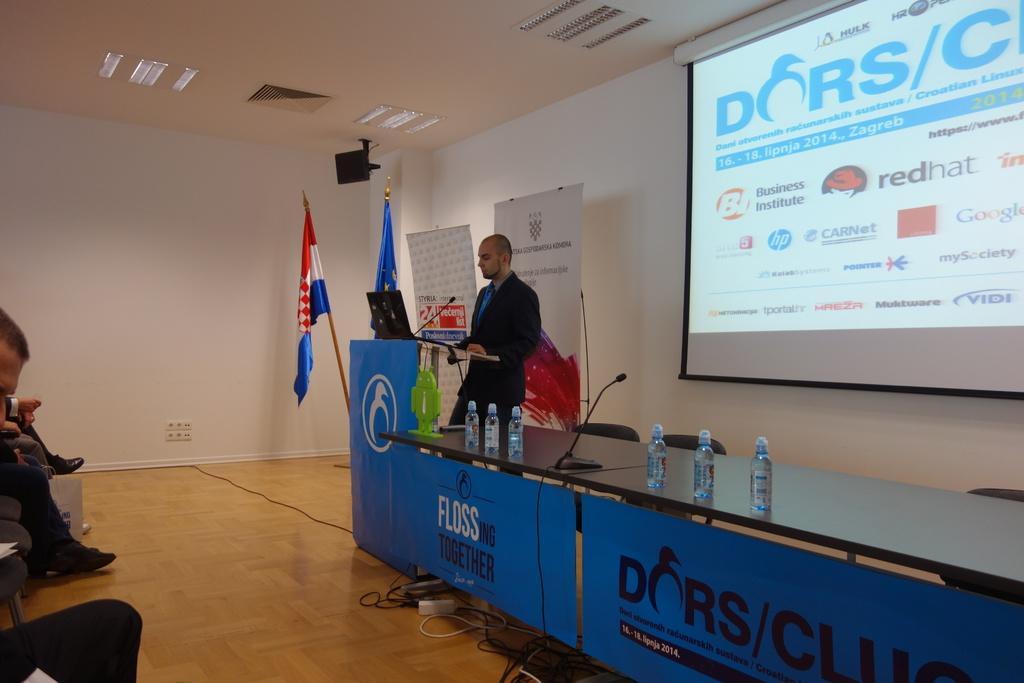Please provide a concise description of this image. In this image I can see a person standing wearing black color blazer, blue color shirt. In front I can see a laptop and a microphone on the podium, right I can see a projector, I can also see two flags in blue, red and white color, banner in white color and the wall is also in white color. 